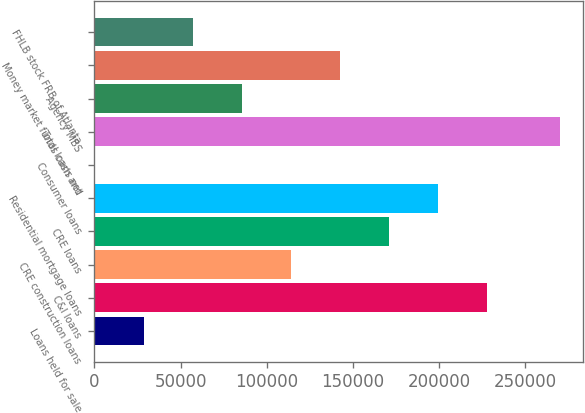Convert chart to OTSL. <chart><loc_0><loc_0><loc_500><loc_500><bar_chart><fcel>Loans held for sale<fcel>C&I loans<fcel>CRE construction loans<fcel>CRE loans<fcel>Residential mortgage loans<fcel>Consumer loans<fcel>Total loans net<fcel>Agency MBS<fcel>Money market funds cash and<fcel>FHLB stock FRB of Atlanta<nl><fcel>28577.4<fcel>227737<fcel>113932<fcel>170834<fcel>199286<fcel>126<fcel>270057<fcel>85480.2<fcel>142383<fcel>57028.8<nl></chart> 